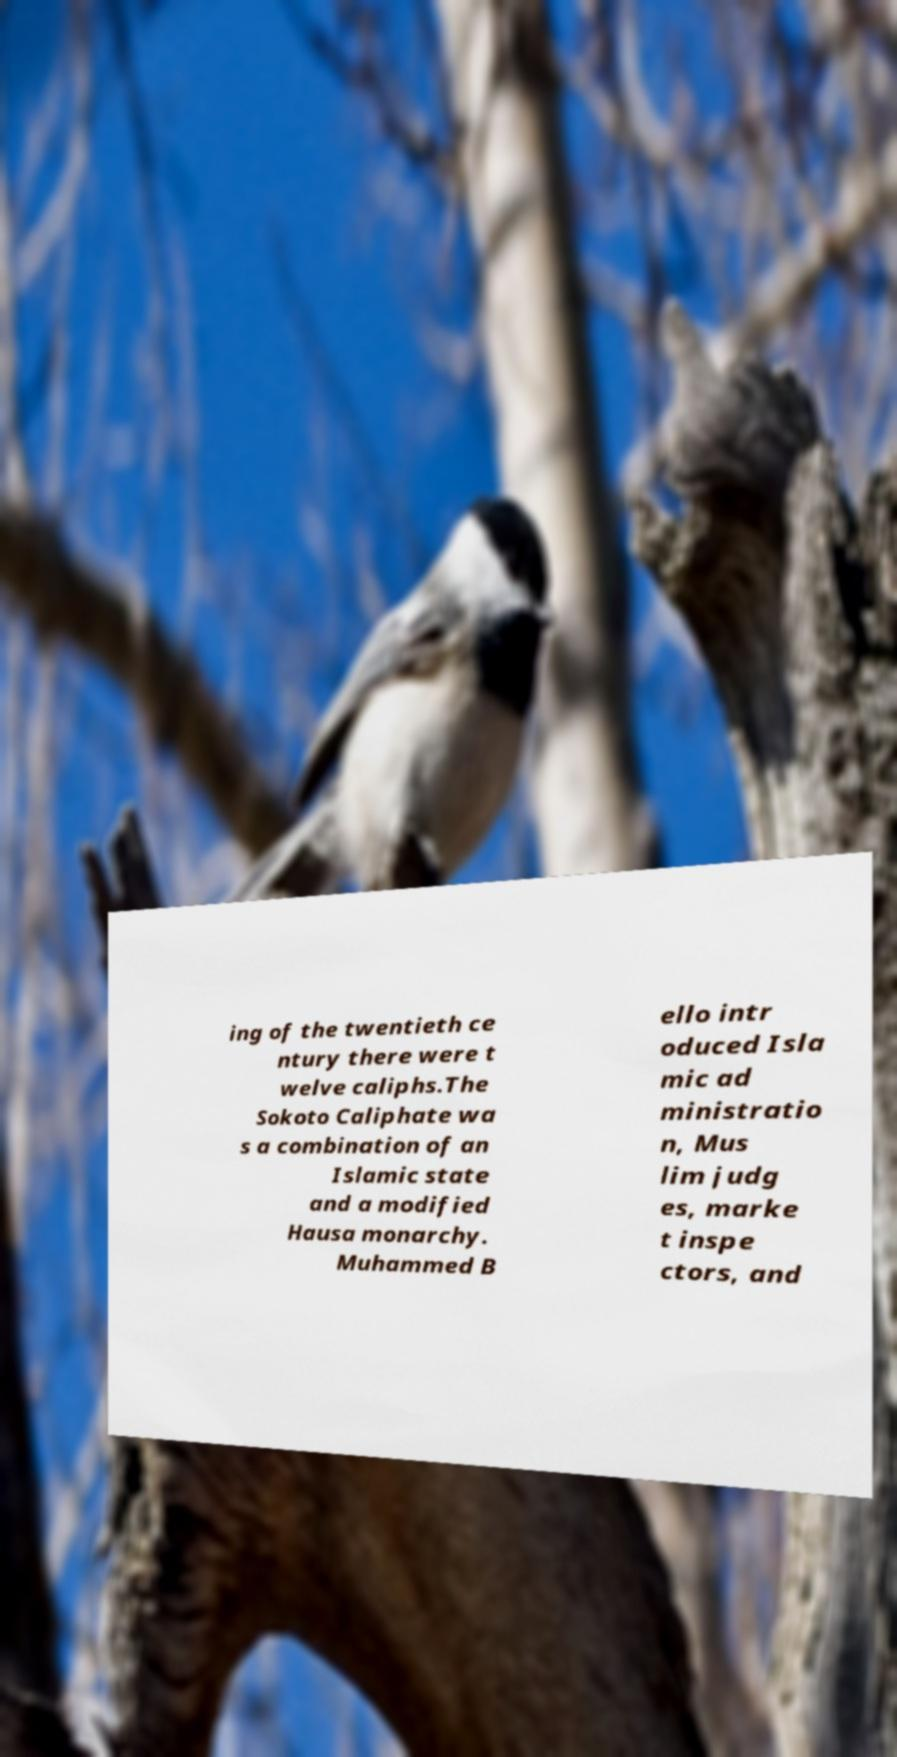Could you extract and type out the text from this image? ing of the twentieth ce ntury there were t welve caliphs.The Sokoto Caliphate wa s a combination of an Islamic state and a modified Hausa monarchy. Muhammed B ello intr oduced Isla mic ad ministratio n, Mus lim judg es, marke t inspe ctors, and 